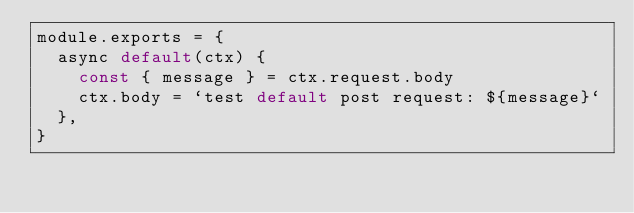Convert code to text. <code><loc_0><loc_0><loc_500><loc_500><_JavaScript_>module.exports = {
  async default(ctx) {
    const { message } = ctx.request.body
    ctx.body = `test default post request: ${message}`
  },
}
</code> 